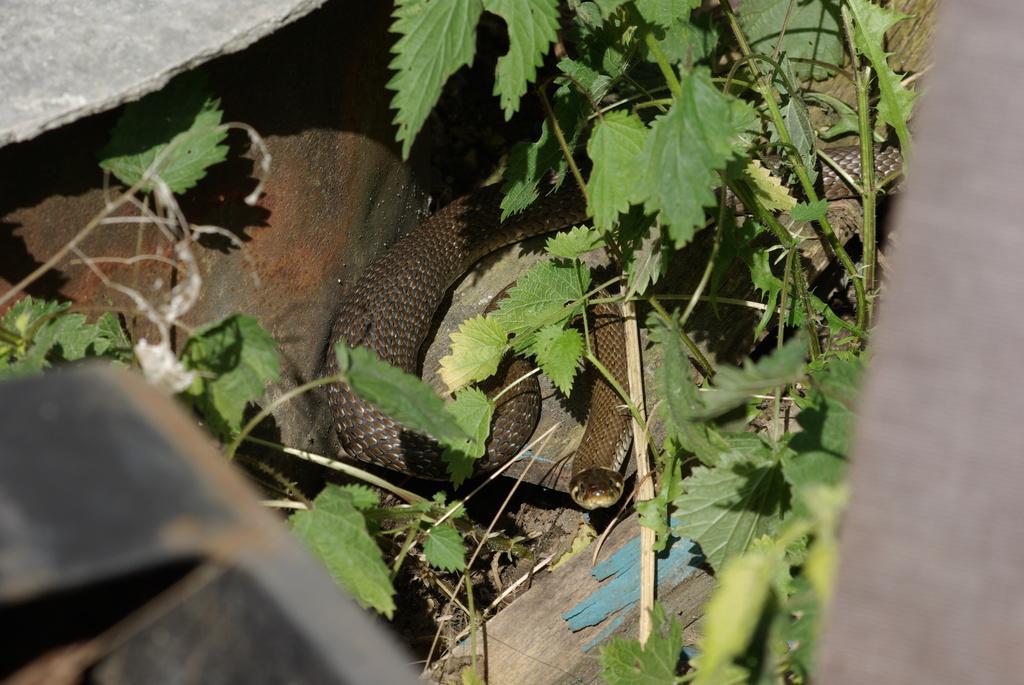Please provide a concise description of this image. In this picture we can see a snake and a plant. 